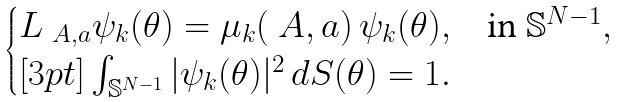Convert formula to latex. <formula><loc_0><loc_0><loc_500><loc_500>\begin{cases} L _ { \ A , a } \psi _ { k } ( \theta ) = \mu _ { k } ( \ A , a ) \, \psi _ { k } ( \theta ) , & \text {in } { \mathbb { S } } ^ { N - 1 } , \\ [ 3 p t ] \int _ { { \mathbb { S } } ^ { N - 1 } } | \psi _ { k } ( \theta ) | ^ { 2 } \, d S ( \theta ) = 1 . \end{cases}</formula> 